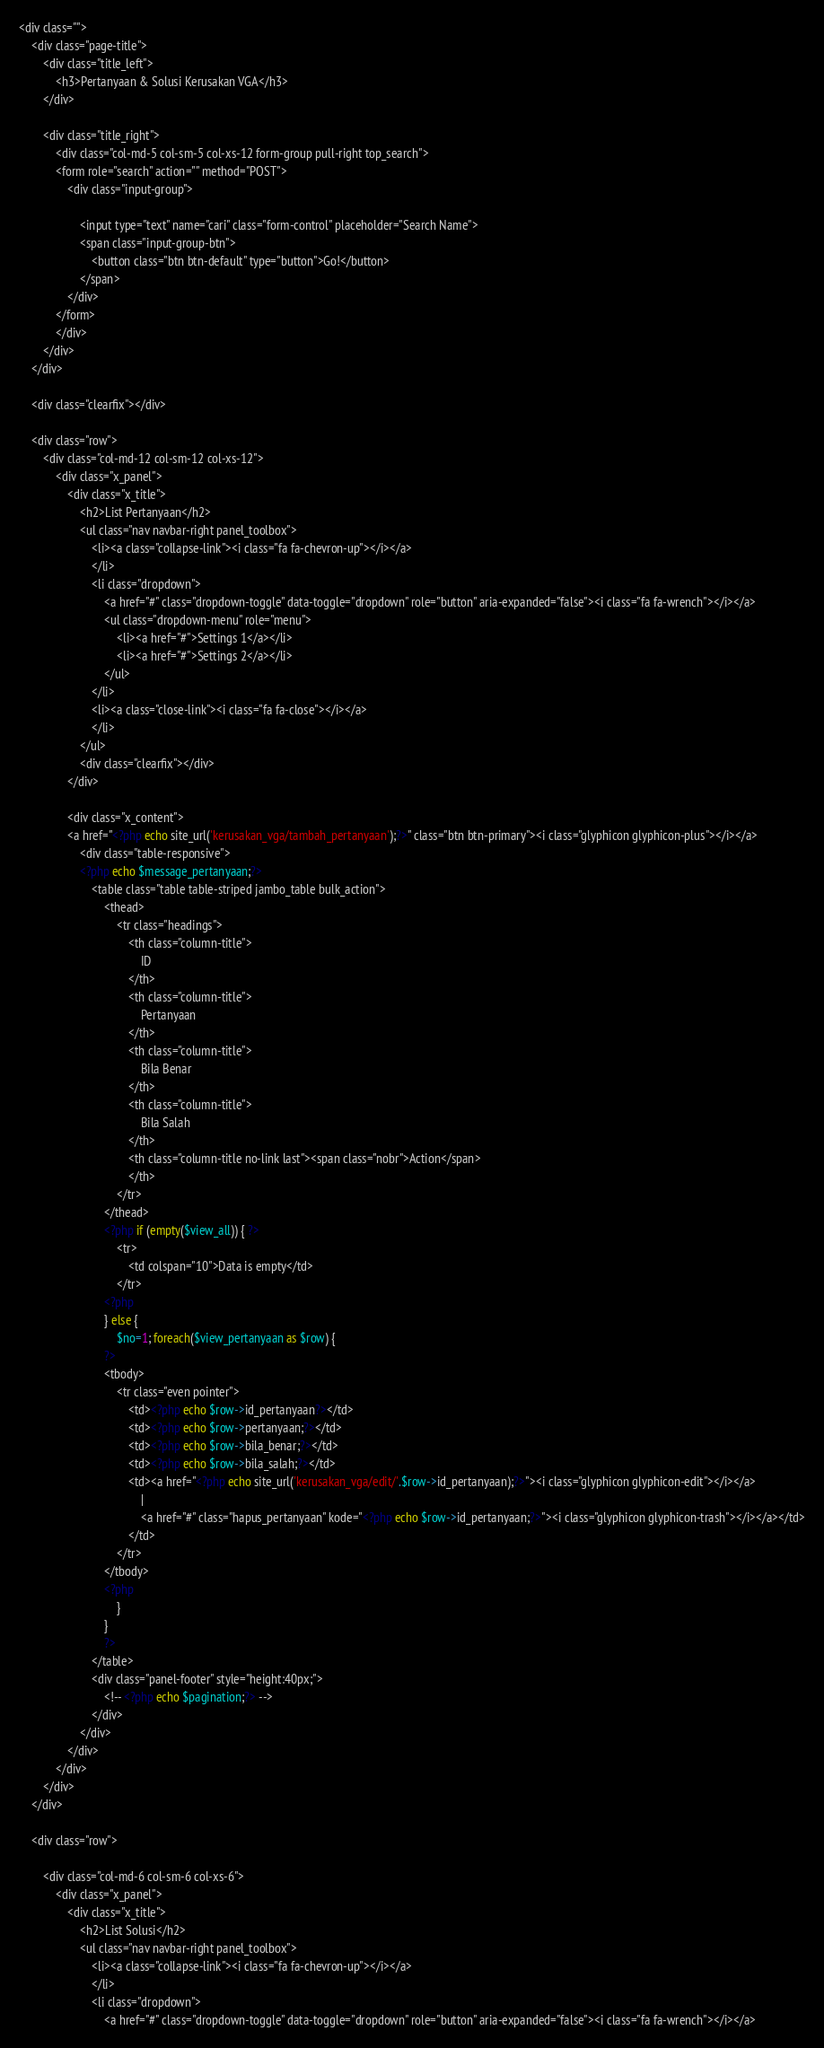Convert code to text. <code><loc_0><loc_0><loc_500><loc_500><_PHP_><div class="">
	<div class="page-title">
		<div class="title_left">
			<h3>Pertanyaan & Solusi Kerusakan VGA</h3>
		</div>

		<div class="title_right">
			<div class="col-md-5 col-sm-5 col-xs-12 form-group pull-right top_search">
			<form role="search" action="" method="POST">
				<div class="input-group">
				
					<input type="text" name="cari" class="form-control" placeholder="Search Name">
					<span class="input-group-btn">
						<button class="btn btn-default" type="button">Go!</button>
					</span>
				</div>
			</form>
			</div>
		</div>
	</div>

	<div class="clearfix"></div>
	
	<div class="row">
		<div class="col-md-12 col-sm-12 col-xs-12">
			<div class="x_panel">
				<div class="x_title">
					<h2>List Pertanyaan</h2>
					<ul class="nav navbar-right panel_toolbox">
						<li><a class="collapse-link"><i class="fa fa-chevron-up"></i></a>
						</li>
						<li class="dropdown">
							<a href="#" class="dropdown-toggle" data-toggle="dropdown" role="button" aria-expanded="false"><i class="fa fa-wrench"></i></a>
							<ul class="dropdown-menu" role="menu">
								<li><a href="#">Settings 1</a></li>
								<li><a href="#">Settings 2</a></li>
							</ul>
						</li>
						<li><a class="close-link"><i class="fa fa-close"></i></a>
						</li>
					</ul>
					<div class="clearfix"></div>
				</div>

				<div class="x_content">
				<a href="<?php echo site_url('kerusakan_vga/tambah_pertanyaan');?>" class="btn btn-primary"><i class="glyphicon glyphicon-plus"></i></a>
					<div class="table-responsive">
					<?php echo $message_pertanyaan;?>
						<table class="table table-striped jambo_table bulk_action">
							<thead>
								<tr class="headings">
									<th class="column-title">
										ID
									</th>
									<th class="column-title">
										Pertanyaan
									</th>
									<th class="column-title">
										Bila Benar
									</th>
									<th class="column-title">
										Bila Salah
									</th>
									<th class="column-title no-link last"><span class="nobr">Action</span>
                            		</th>
								</tr>
							</thead>
							<?php if (empty($view_all)) { ?>
								<tr>
									<td colspan="10">Data is empty</td>
								</tr>
							<?php
							} else {
								$no=1; foreach($view_pertanyaan as $row) {
							?>
							<tbody>
								<tr class="even pointer">
									<td><?php echo $row->id_pertanyaan?></td>
									<td><?php echo $row->pertanyaan;?></td>
									<td><?php echo $row->bila_benar;?></td>
									<td><?php echo $row->bila_salah;?></td>
									<td><a href="<?php echo site_url('kerusakan_vga/edit/'.$row->id_pertanyaan);?>"><i class="glyphicon glyphicon-edit"></i></a>
										|
										<a href="#" class="hapus_pertanyaan" kode="<?php echo $row->id_pertanyaan;?>"><i class="glyphicon glyphicon-trash"></i></a></td>
									</td>
								</tr>
							</tbody>
							<?php
								}
							}
							?>
						</table>
						<div class="panel-footer" style="height:40px;">
							<!-- <?php echo $pagination;?> -->
						</div>
					</div>
				</div>
			</div>
		</div>
	</div>

	<div class="row">

		<div class="col-md-6 col-sm-6 col-xs-6">
			<div class="x_panel">
				<div class="x_title">
					<h2>List Solusi</h2>
					<ul class="nav navbar-right panel_toolbox">
						<li><a class="collapse-link"><i class="fa fa-chevron-up"></i></a>
						</li>
						<li class="dropdown">
							<a href="#" class="dropdown-toggle" data-toggle="dropdown" role="button" aria-expanded="false"><i class="fa fa-wrench"></i></a></code> 